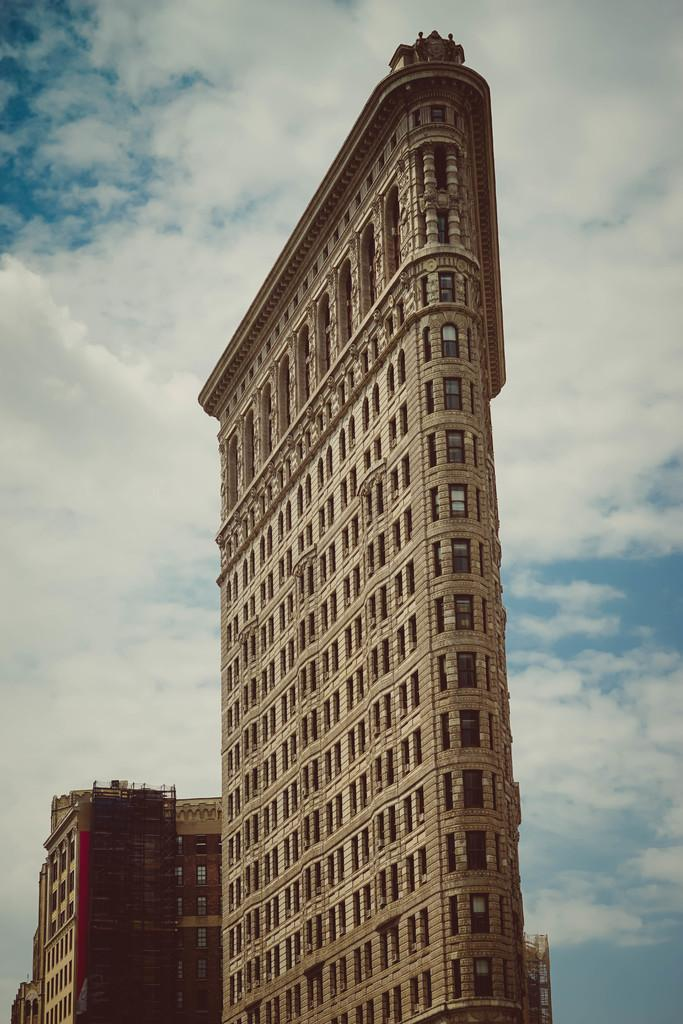What structures are visible in the image? There are buildings in the image. What can be seen in the sky in the background of the image? There are clouds in the sky in the background of the image. Can you see a squirrel climbing the buildings in the image? There is no squirrel present in the image, and it is not climbing any buildings. Are there any ghosts visible in the image? There are no ghosts present in the image. 